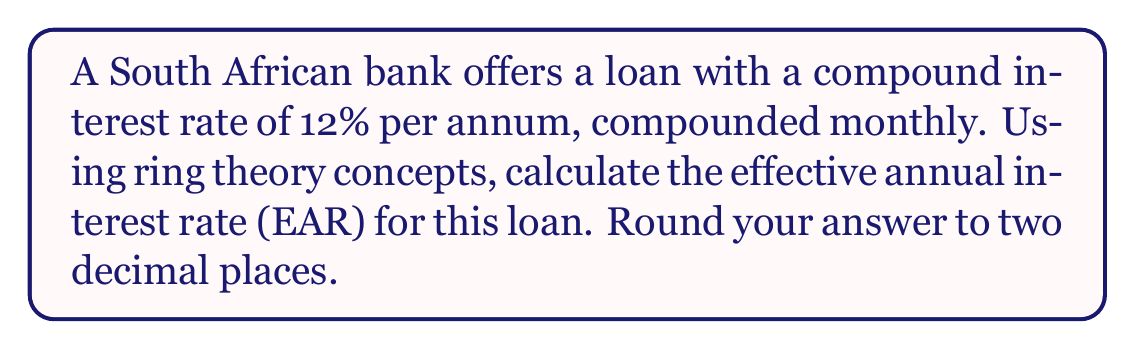Solve this math problem. To solve this problem using ring theory concepts, we can consider the interest rate calculations as operations within a ring structure.

1. First, let's define our ring:
   Let $R$ be the ring of real numbers under addition and multiplication.

2. In this ring, we can define an operation for calculating compound interest:
   $f(x) = (1 + \frac{r}{n})^n - 1$
   where $r$ is the annual interest rate and $n$ is the number of compounding periods per year.

3. In our case:
   $r = 0.12$ (12% annual rate)
   $n = 12$ (compounded monthly)

4. Substituting these values into our function:
   $f(0.12) = (1 + \frac{0.12}{12})^{12} - 1$

5. Simplifying:
   $f(0.12) = (1 + 0.01)^{12} - 1$

6. Using the properties of exponents in our ring:
   $f(0.12) = 1.01^{12} - 1$

7. Calculating:
   $f(0.12) = 1.126825 - 1 = 0.126825$

8. Converting to a percentage and rounding to two decimal places:
   $0.126825 \times 100 \approx 12.68\%$

This calculation demonstrates the use of ring theory concepts, particularly the properties of exponents and the closure of real numbers under addition and multiplication.
Answer: The effective annual interest rate (EAR) is approximately 12.68%. 